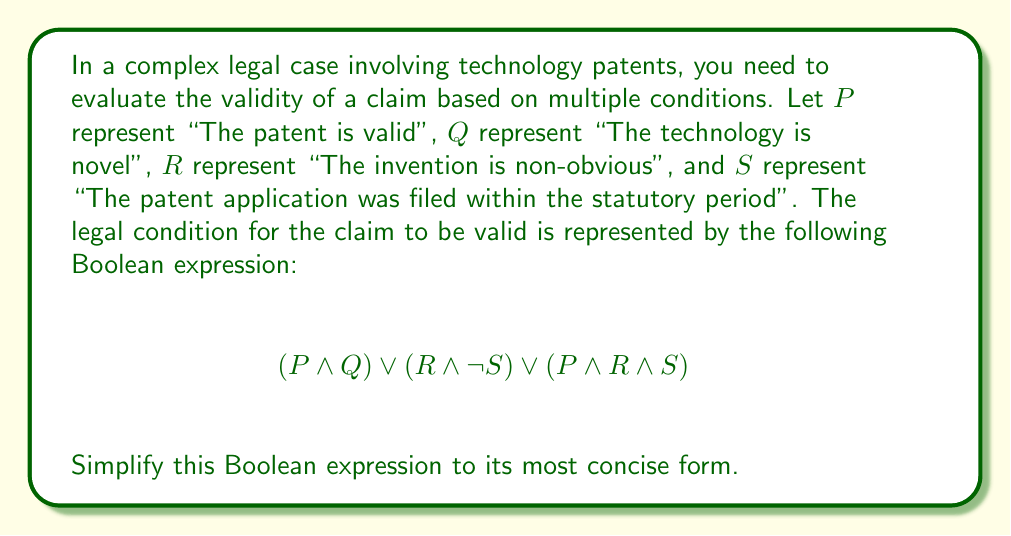Give your solution to this math problem. To simplify this Boolean expression, we'll use the laws of Boolean algebra:

1) First, let's distribute $P$ over $(R \land S)$ in the last term:
   $$(P \land Q) \lor (R \land \neg S) \lor ((P \land R) \land S)$$

2) Now, we can use the associative property to group $P \land R$:
   $$(P \land Q) \lor (R \land \neg S) \lor (P \land R \land S)$$

3) We can factor out $R$ from the last two terms:
   $$(P \land Q) \lor (R \land (\neg S \lor (P \land S)))$$

4) Inside the parentheses, we can distribute $P$ over $S$:
   $$(P \land Q) \lor (R \land (\neg S \lor P))$$

5) The expression $\neg S \lor P$ can be rewritten as $S \rightarrow P$ (if $S$, then $P$).
   $$(P \land Q) \lor (R \land (S \rightarrow P))$$

6) This is the most simplified form we can achieve without losing any of the original meaning.

This simplified form tells us that the claim is valid if either:
- The patent is valid and the technology is novel, or
- The invention is non-obvious and (if the application was filed within the statutory period, then the patent is valid).
Answer: $$(P \land Q) \lor (R \land (S \rightarrow P))$$ 